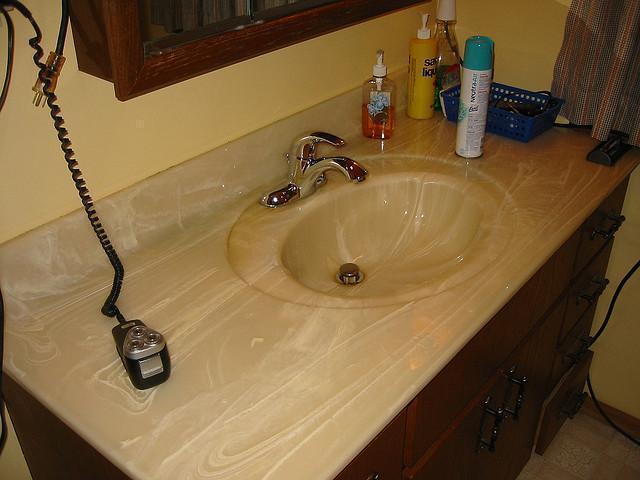What is the corded object called?
From the following set of four choices, select the accurate answer to respond to the question.
Options: Hair iron, phone, electric razor, hair dryer. Electric razor. 